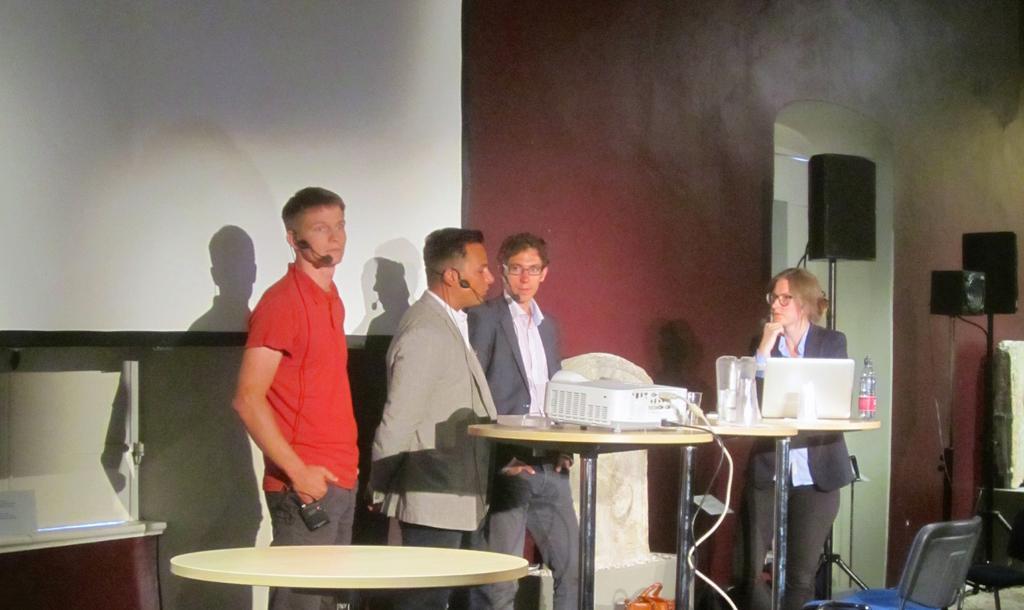Please provide a concise description of this image. As we can see in the image, there is a white color wall, four people standing over here. In front of them there is a table. On table there is a projector and on the right side there is a sound box and a chair. 